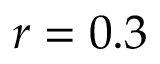<formula> <loc_0><loc_0><loc_500><loc_500>r = 0 . 3</formula> 